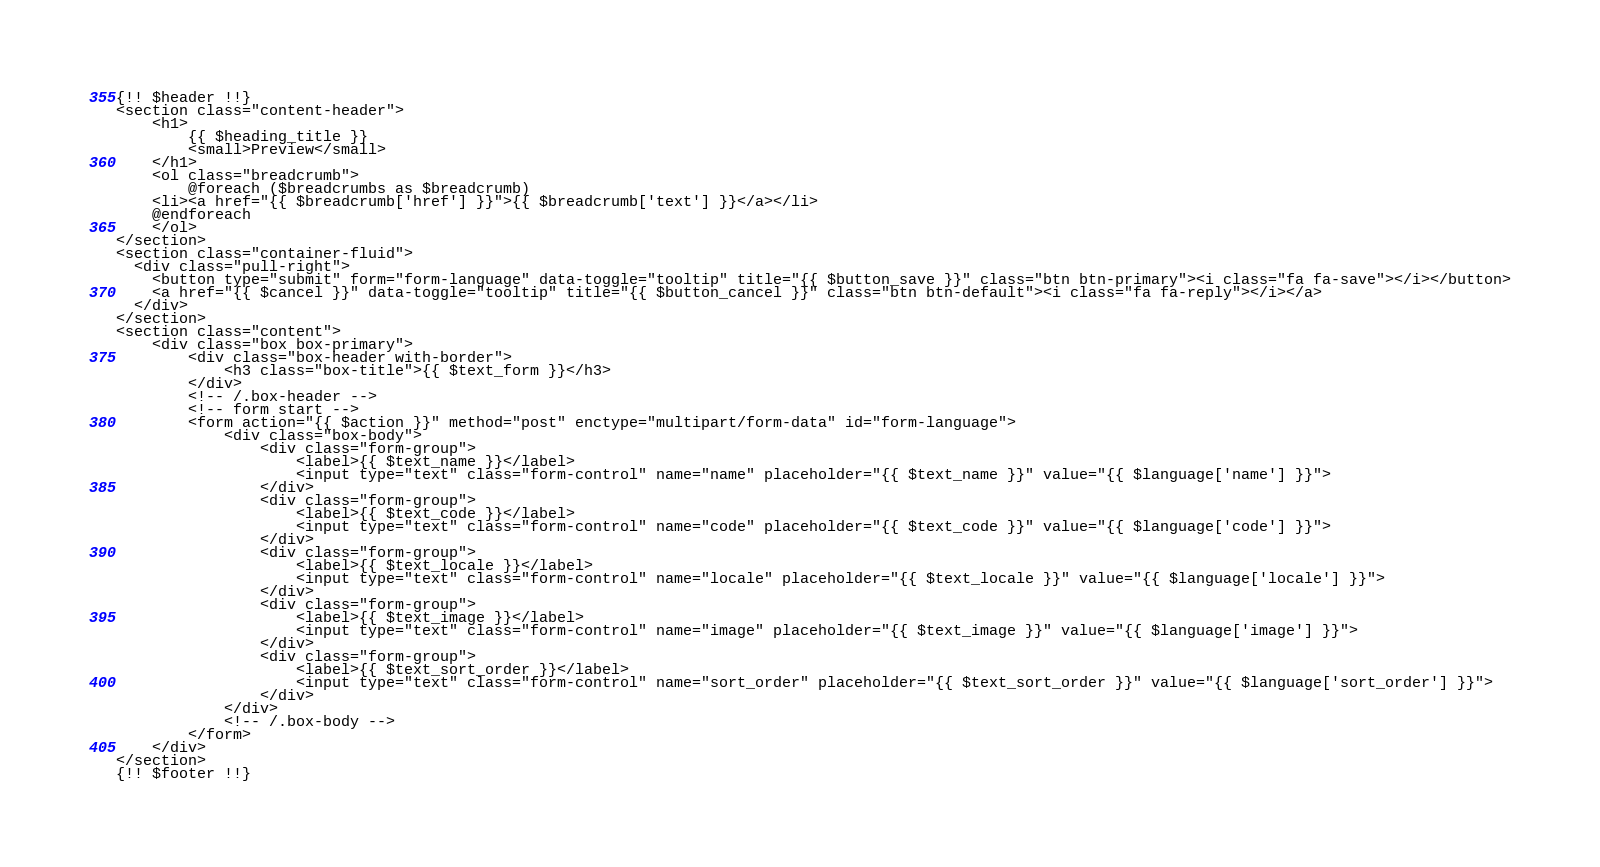Convert code to text. <code><loc_0><loc_0><loc_500><loc_500><_PHP_>{!! $header !!}
<section class="content-header">
	<h1>
		{{ $heading_title }}
		<small>Preview</small>
	</h1>
	<ol class="breadcrumb">
		@foreach ($breadcrumbs as $breadcrumb)
    <li><a href="{{ $breadcrumb['href'] }}">{{ $breadcrumb['text'] }}</a></li>
    @endforeach
	</ol>
</section>
<section class="container-fluid">
  <div class="pull-right">
    <button type="submit" form="form-language" data-toggle="tooltip" title="{{ $button_save }}" class="btn btn-primary"><i class="fa fa-save"></i></button>
    <a href="{{ $cancel }}" data-toggle="tooltip" title="{{ $button_cancel }}" class="btn btn-default"><i class="fa fa-reply"></i></a>
  </div>
</section>
<section class="content">
	<div class="box box-primary">
		<div class="box-header with-border">
			<h3 class="box-title">{{ $text_form }}</h3>
		</div>
		<!-- /.box-header -->
		<!-- form start -->
		<form action="{{ $action }}" method="post" enctype="multipart/form-data" id="form-language">
			<div class="box-body">
				<div class="form-group">
					<label>{{ $text_name }}</label>
					<input type="text" class="form-control" name="name" placeholder="{{ $text_name }}" value="{{ $language['name'] }}">
				</div>
				<div class="form-group">
					<label>{{ $text_code }}</label>
					<input type="text" class="form-control" name="code" placeholder="{{ $text_code }}" value="{{ $language['code'] }}">
				</div>
				<div class="form-group">
					<label>{{ $text_locale }}</label>
					<input type="text" class="form-control" name="locale" placeholder="{{ $text_locale }}" value="{{ $language['locale'] }}">
				</div>
				<div class="form-group">
					<label>{{ $text_image }}</label>
					<input type="text" class="form-control" name="image" placeholder="{{ $text_image }}" value="{{ $language['image'] }}">
				</div>
				<div class="form-group">
					<label>{{ $text_sort_order }}</label>
					<input type="text" class="form-control" name="sort_order" placeholder="{{ $text_sort_order }}" value="{{ $language['sort_order'] }}">
				</div>
			</div>
			<!-- /.box-body -->
		</form>
	</div>
</section>
{!! $footer !!}</code> 